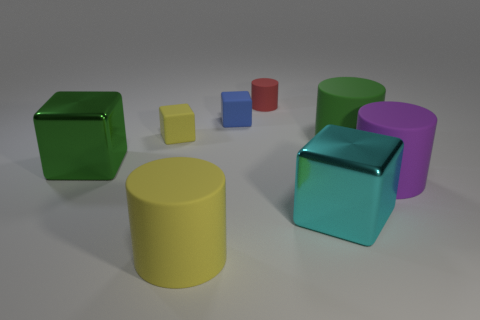Add 1 large green cylinders. How many objects exist? 9 Subtract all yellow matte cubes. How many cubes are left? 3 Subtract 1 yellow cylinders. How many objects are left? 7 Subtract 1 blocks. How many blocks are left? 3 Subtract all yellow cylinders. Subtract all green cubes. How many cylinders are left? 3 Subtract all yellow cylinders. How many yellow blocks are left? 1 Subtract all big rubber things. Subtract all large things. How many objects are left? 0 Add 7 tiny blue objects. How many tiny blue objects are left? 8 Add 6 blue rubber things. How many blue rubber things exist? 7 Subtract all cyan blocks. How many blocks are left? 3 